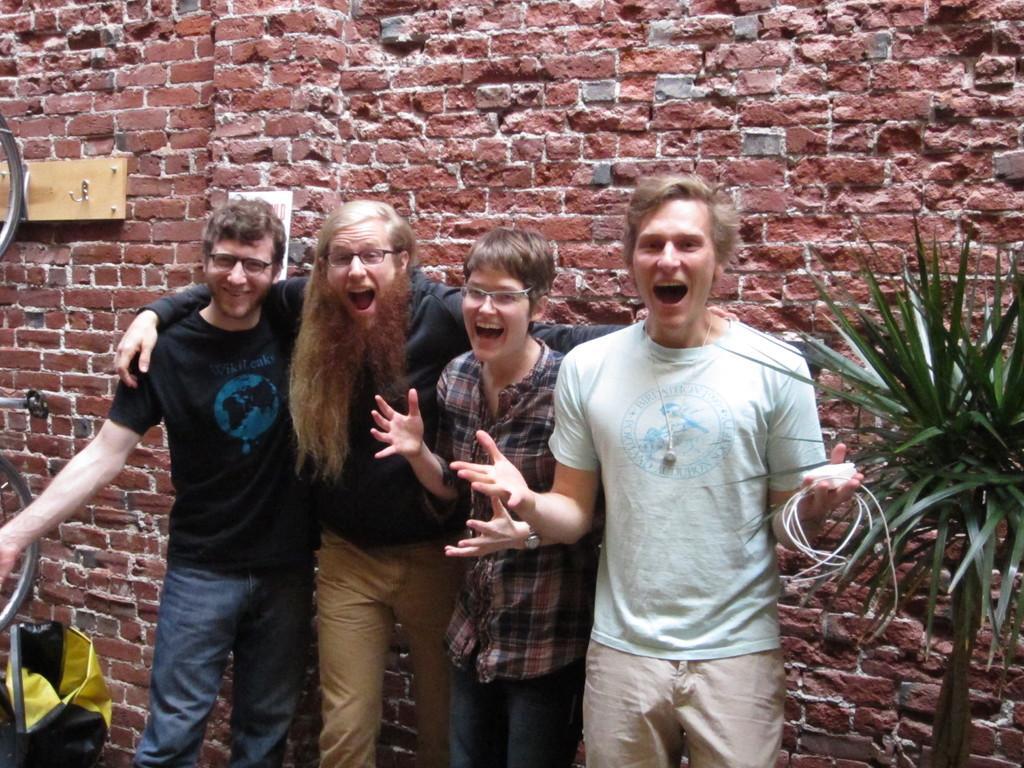Describe this image in one or two sentences. In this image I can see four people standing and wearing the different color dresses. I can see three people wearing the specs and one person is holding the wire. To the right I can see the wire. To the left there are wheels and the bag. In the background I can see the brown color brick wall. 